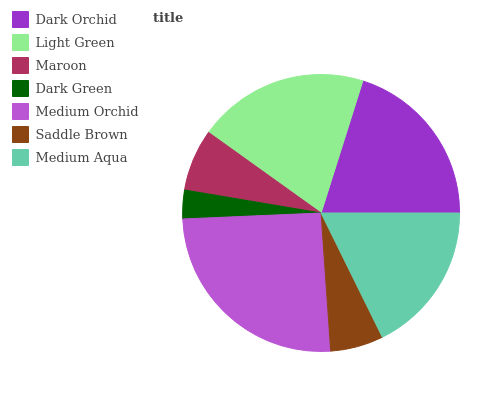Is Dark Green the minimum?
Answer yes or no. Yes. Is Medium Orchid the maximum?
Answer yes or no. Yes. Is Light Green the minimum?
Answer yes or no. No. Is Light Green the maximum?
Answer yes or no. No. Is Dark Orchid greater than Light Green?
Answer yes or no. Yes. Is Light Green less than Dark Orchid?
Answer yes or no. Yes. Is Light Green greater than Dark Orchid?
Answer yes or no. No. Is Dark Orchid less than Light Green?
Answer yes or no. No. Is Medium Aqua the high median?
Answer yes or no. Yes. Is Medium Aqua the low median?
Answer yes or no. Yes. Is Dark Green the high median?
Answer yes or no. No. Is Maroon the low median?
Answer yes or no. No. 